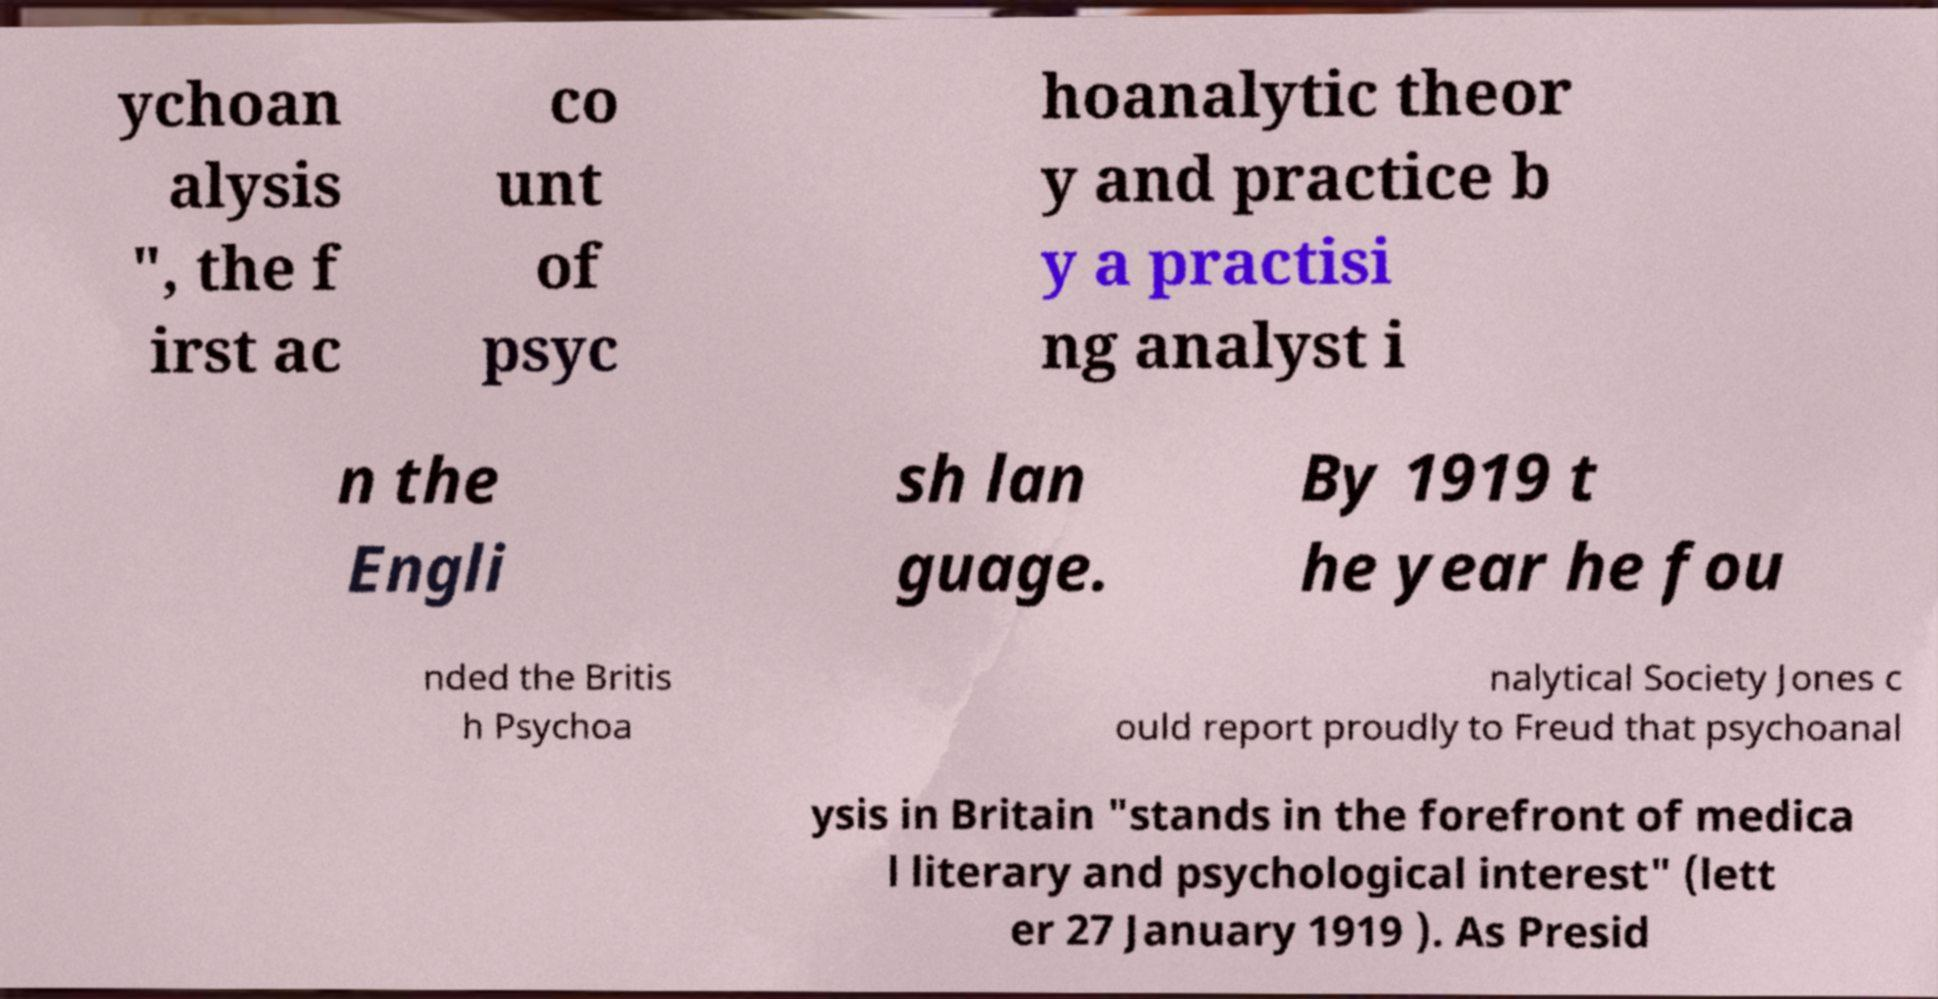Please read and relay the text visible in this image. What does it say? ychoan alysis ", the f irst ac co unt of psyc hoanalytic theor y and practice b y a practisi ng analyst i n the Engli sh lan guage. By 1919 t he year he fou nded the Britis h Psychoa nalytical Society Jones c ould report proudly to Freud that psychoanal ysis in Britain "stands in the forefront of medica l literary and psychological interest" (lett er 27 January 1919 ). As Presid 